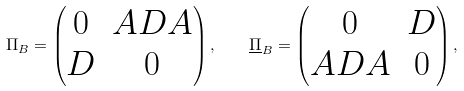Convert formula to latex. <formula><loc_0><loc_0><loc_500><loc_500>\Pi _ { B } = \begin{pmatrix} 0 & A D A \\ D & 0 \end{pmatrix} , \quad \underline { \Pi } _ { B } = \begin{pmatrix} 0 & D \\ A D A & 0 \end{pmatrix} ,</formula> 